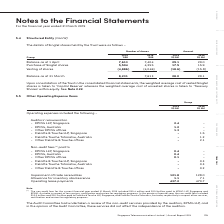According to Singapore Telecommunications's financial document, What is the key focus of note 5.5? Other Operating Expense Items. The document states: "5.5 Other Operating Expense Items..." Also, Does the non-audit services provided by KPMG LLP affect their independence? these services did not affect the independence of the auditors. The document states: "G LLP, and in the opinion of the Audit Committee, these services did not affect the independence of the auditors. G LLP, and in the opinion of the Aud..." Also, What services do the non-audit fees pertain to? tax services, certification and review for regulatory purposes. The document states: "LLP, Singapore and KPMG, Australia in respect of tax services, certification and review for regulatory purposes. In the previous financial year, the n..." Also, How many categories of operating expenses are there? Counting the relevant items in the document: Auditors' remuneration,  Non-audit fees,  Impairment of trade receivables,  Allowance for inventory obsolescence,  Operating lease payments, I find 5 instances. The key data points involved are: Allowance for inventory obsolescence, Auditors' remuneration, Impairment of trade receivables. Additionally, In which year was there a higher total audit fee paid? According to the financial document, 2019. The relevant text states: "Group 2019 ‘000 2018 ‘000 2019 S$ Mil 2018 S$ Mil..." Also, can you calculate: What is the average impairment of trade receivables across the 2 years? To answer this question, I need to perform calculations using the financial data. The calculation is: (128 + 121.8)/2, which equals 124.9 (in millions). This is based on the information: "Impairment of trade receivables 121.8 128.0 Allowance for inventory obsolescence 1.1 7.1 Operating lease payments 437.2 470.7 Impairment of trade receivables 121.8 128.0 Allowance for inventory obsole..." The key data points involved are: 121.8, 128. 